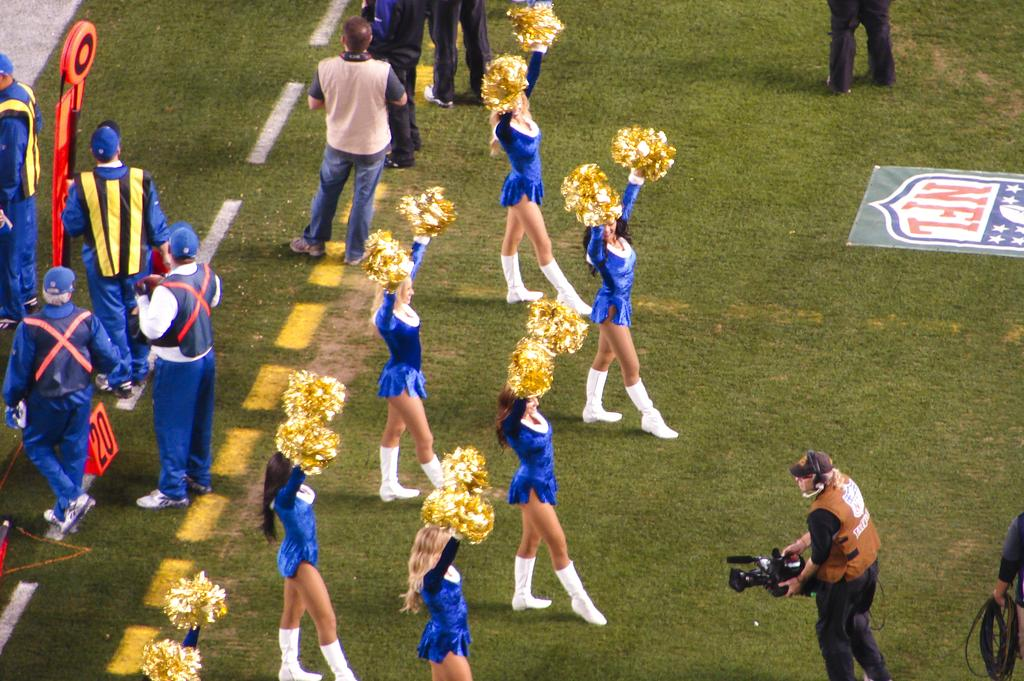<image>
Summarize the visual content of the image. The cheerleaders are on the field at an NFL game. 